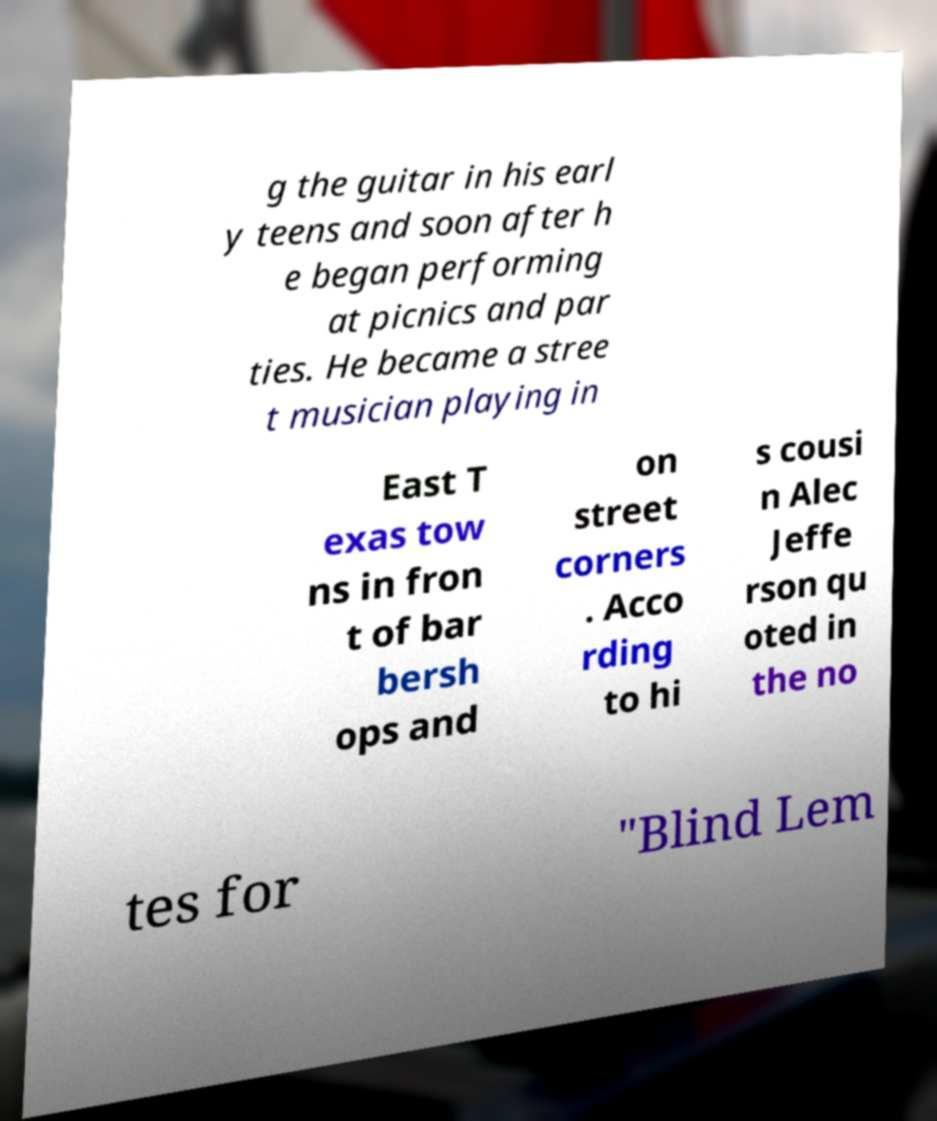There's text embedded in this image that I need extracted. Can you transcribe it verbatim? g the guitar in his earl y teens and soon after h e began performing at picnics and par ties. He became a stree t musician playing in East T exas tow ns in fron t of bar bersh ops and on street corners . Acco rding to hi s cousi n Alec Jeffe rson qu oted in the no tes for "Blind Lem 